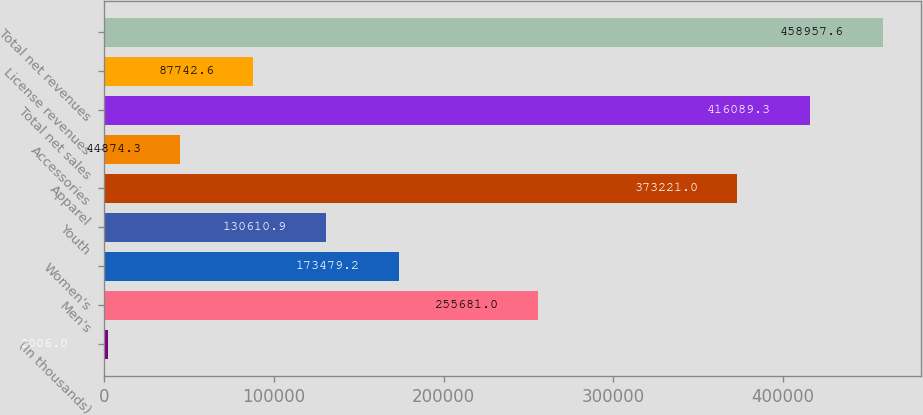<chart> <loc_0><loc_0><loc_500><loc_500><bar_chart><fcel>(In thousands)<fcel>Men's<fcel>Women's<fcel>Youth<fcel>Apparel<fcel>Accessories<fcel>Total net sales<fcel>License revenues<fcel>Total net revenues<nl><fcel>2006<fcel>255681<fcel>173479<fcel>130611<fcel>373221<fcel>44874.3<fcel>416089<fcel>87742.6<fcel>458958<nl></chart> 